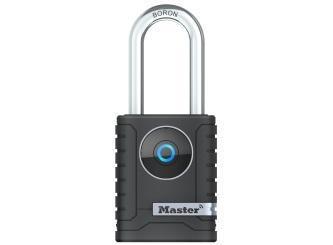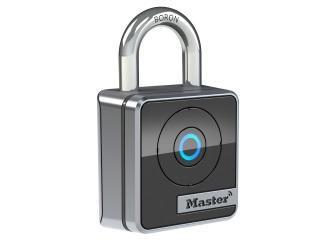The first image is the image on the left, the second image is the image on the right. For the images shown, is this caption "Each image contains just one lock, which is upright and has a blue circle on the front." true? Answer yes or no. Yes. The first image is the image on the left, the second image is the image on the right. Given the left and right images, does the statement "Exactly two locks are shown, both of them locked and with a circular design and logo on the front, one with ridges on each side." hold true? Answer yes or no. Yes. 